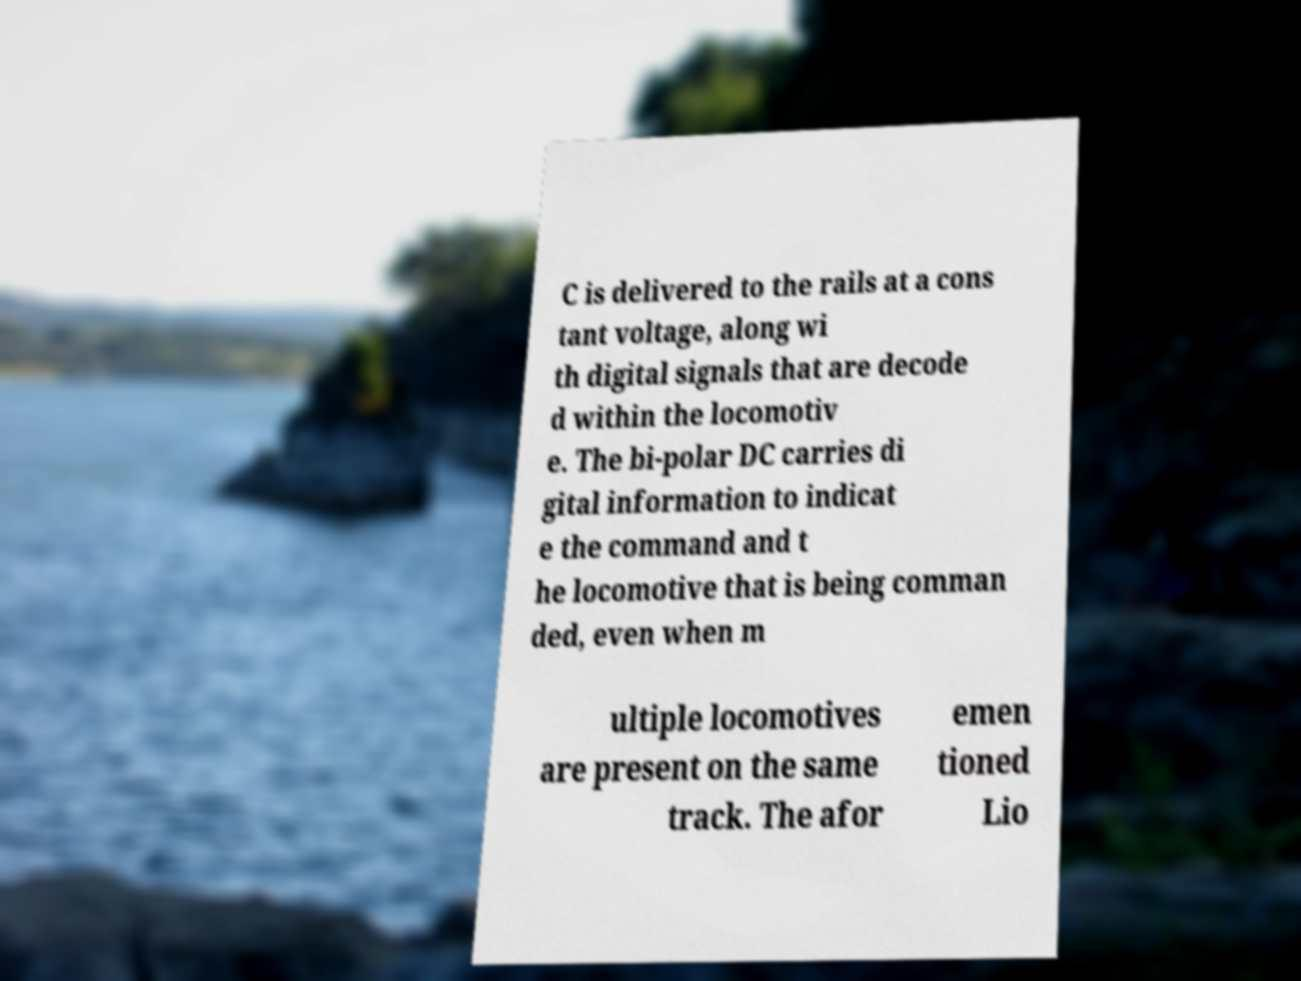Could you extract and type out the text from this image? C is delivered to the rails at a cons tant voltage, along wi th digital signals that are decode d within the locomotiv e. The bi-polar DC carries di gital information to indicat e the command and t he locomotive that is being comman ded, even when m ultiple locomotives are present on the same track. The afor emen tioned Lio 